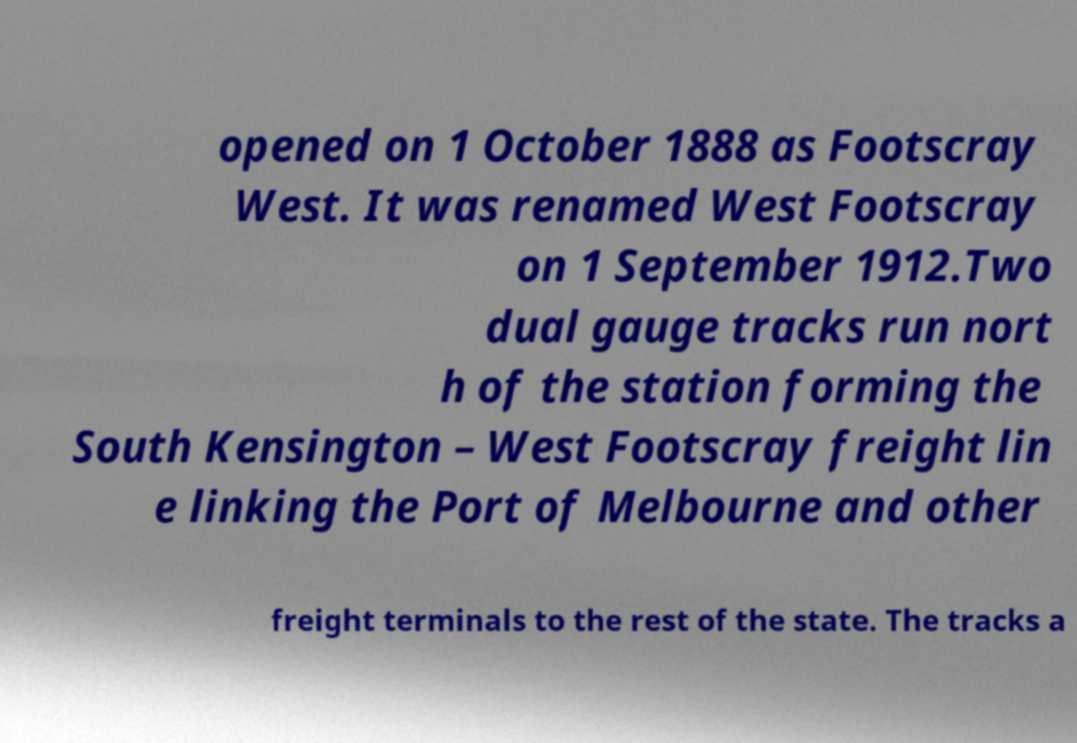For documentation purposes, I need the text within this image transcribed. Could you provide that? opened on 1 October 1888 as Footscray West. It was renamed West Footscray on 1 September 1912.Two dual gauge tracks run nort h of the station forming the South Kensington – West Footscray freight lin e linking the Port of Melbourne and other freight terminals to the rest of the state. The tracks a 